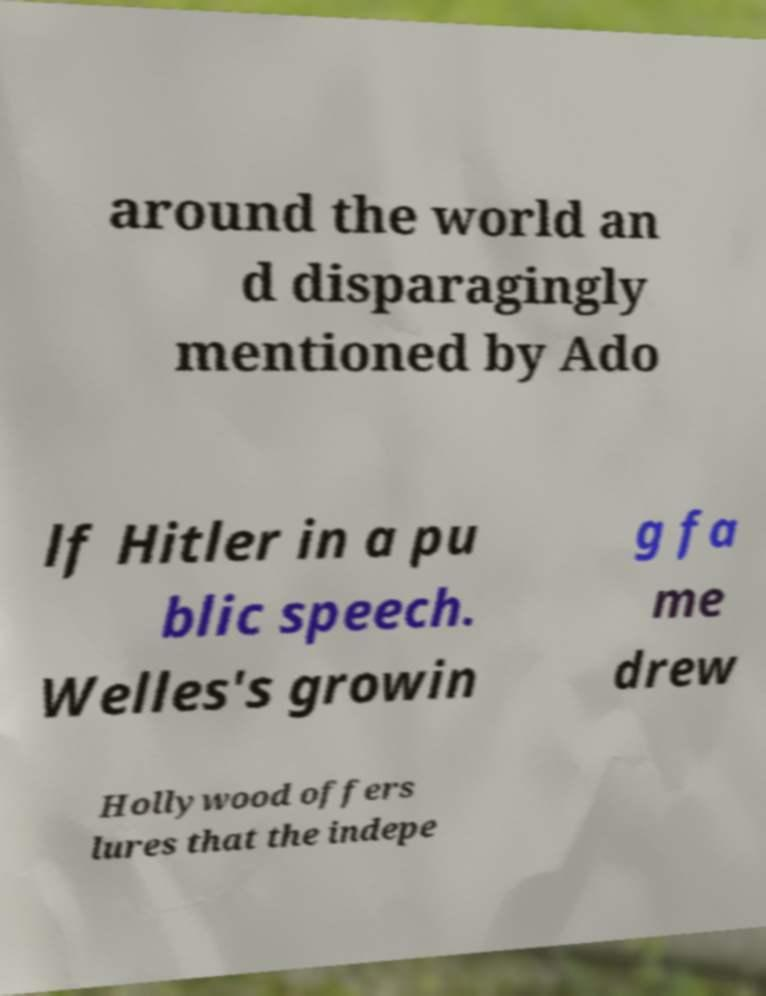For documentation purposes, I need the text within this image transcribed. Could you provide that? around the world an d disparagingly mentioned by Ado lf Hitler in a pu blic speech. Welles's growin g fa me drew Hollywood offers lures that the indepe 